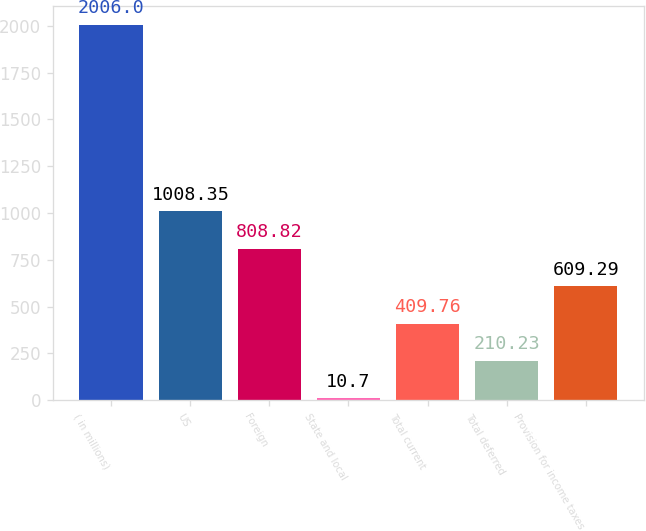Convert chart to OTSL. <chart><loc_0><loc_0><loc_500><loc_500><bar_chart><fcel>( in millions)<fcel>US<fcel>Foreign<fcel>State and local<fcel>Total current<fcel>Total deferred<fcel>Provision for income taxes<nl><fcel>2006<fcel>1008.35<fcel>808.82<fcel>10.7<fcel>409.76<fcel>210.23<fcel>609.29<nl></chart> 